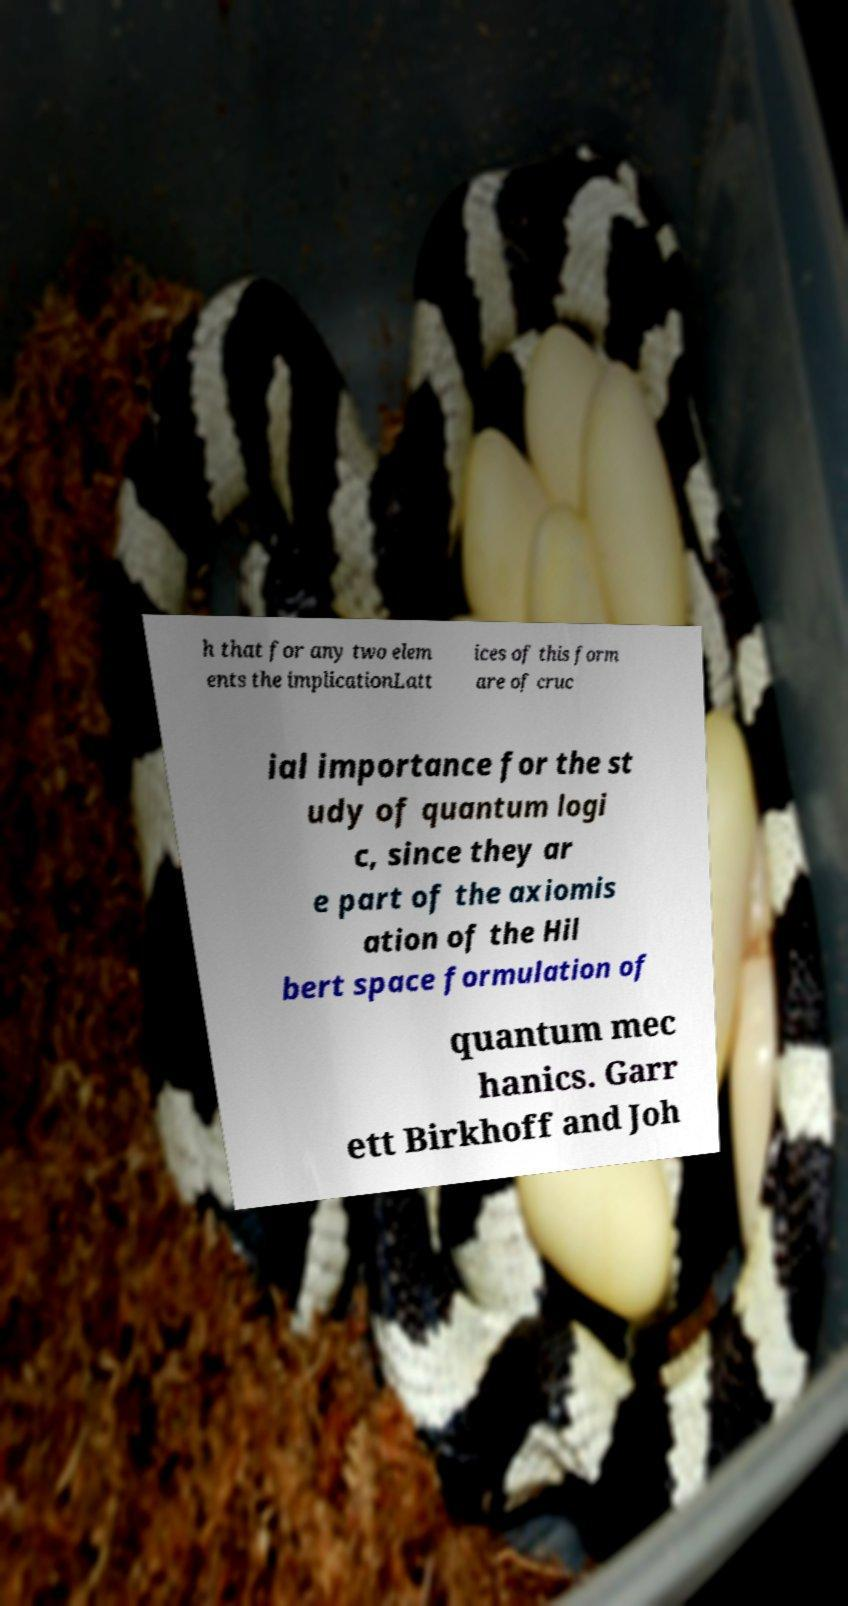What messages or text are displayed in this image? I need them in a readable, typed format. h that for any two elem ents the implicationLatt ices of this form are of cruc ial importance for the st udy of quantum logi c, since they ar e part of the axiomis ation of the Hil bert space formulation of quantum mec hanics. Garr ett Birkhoff and Joh 